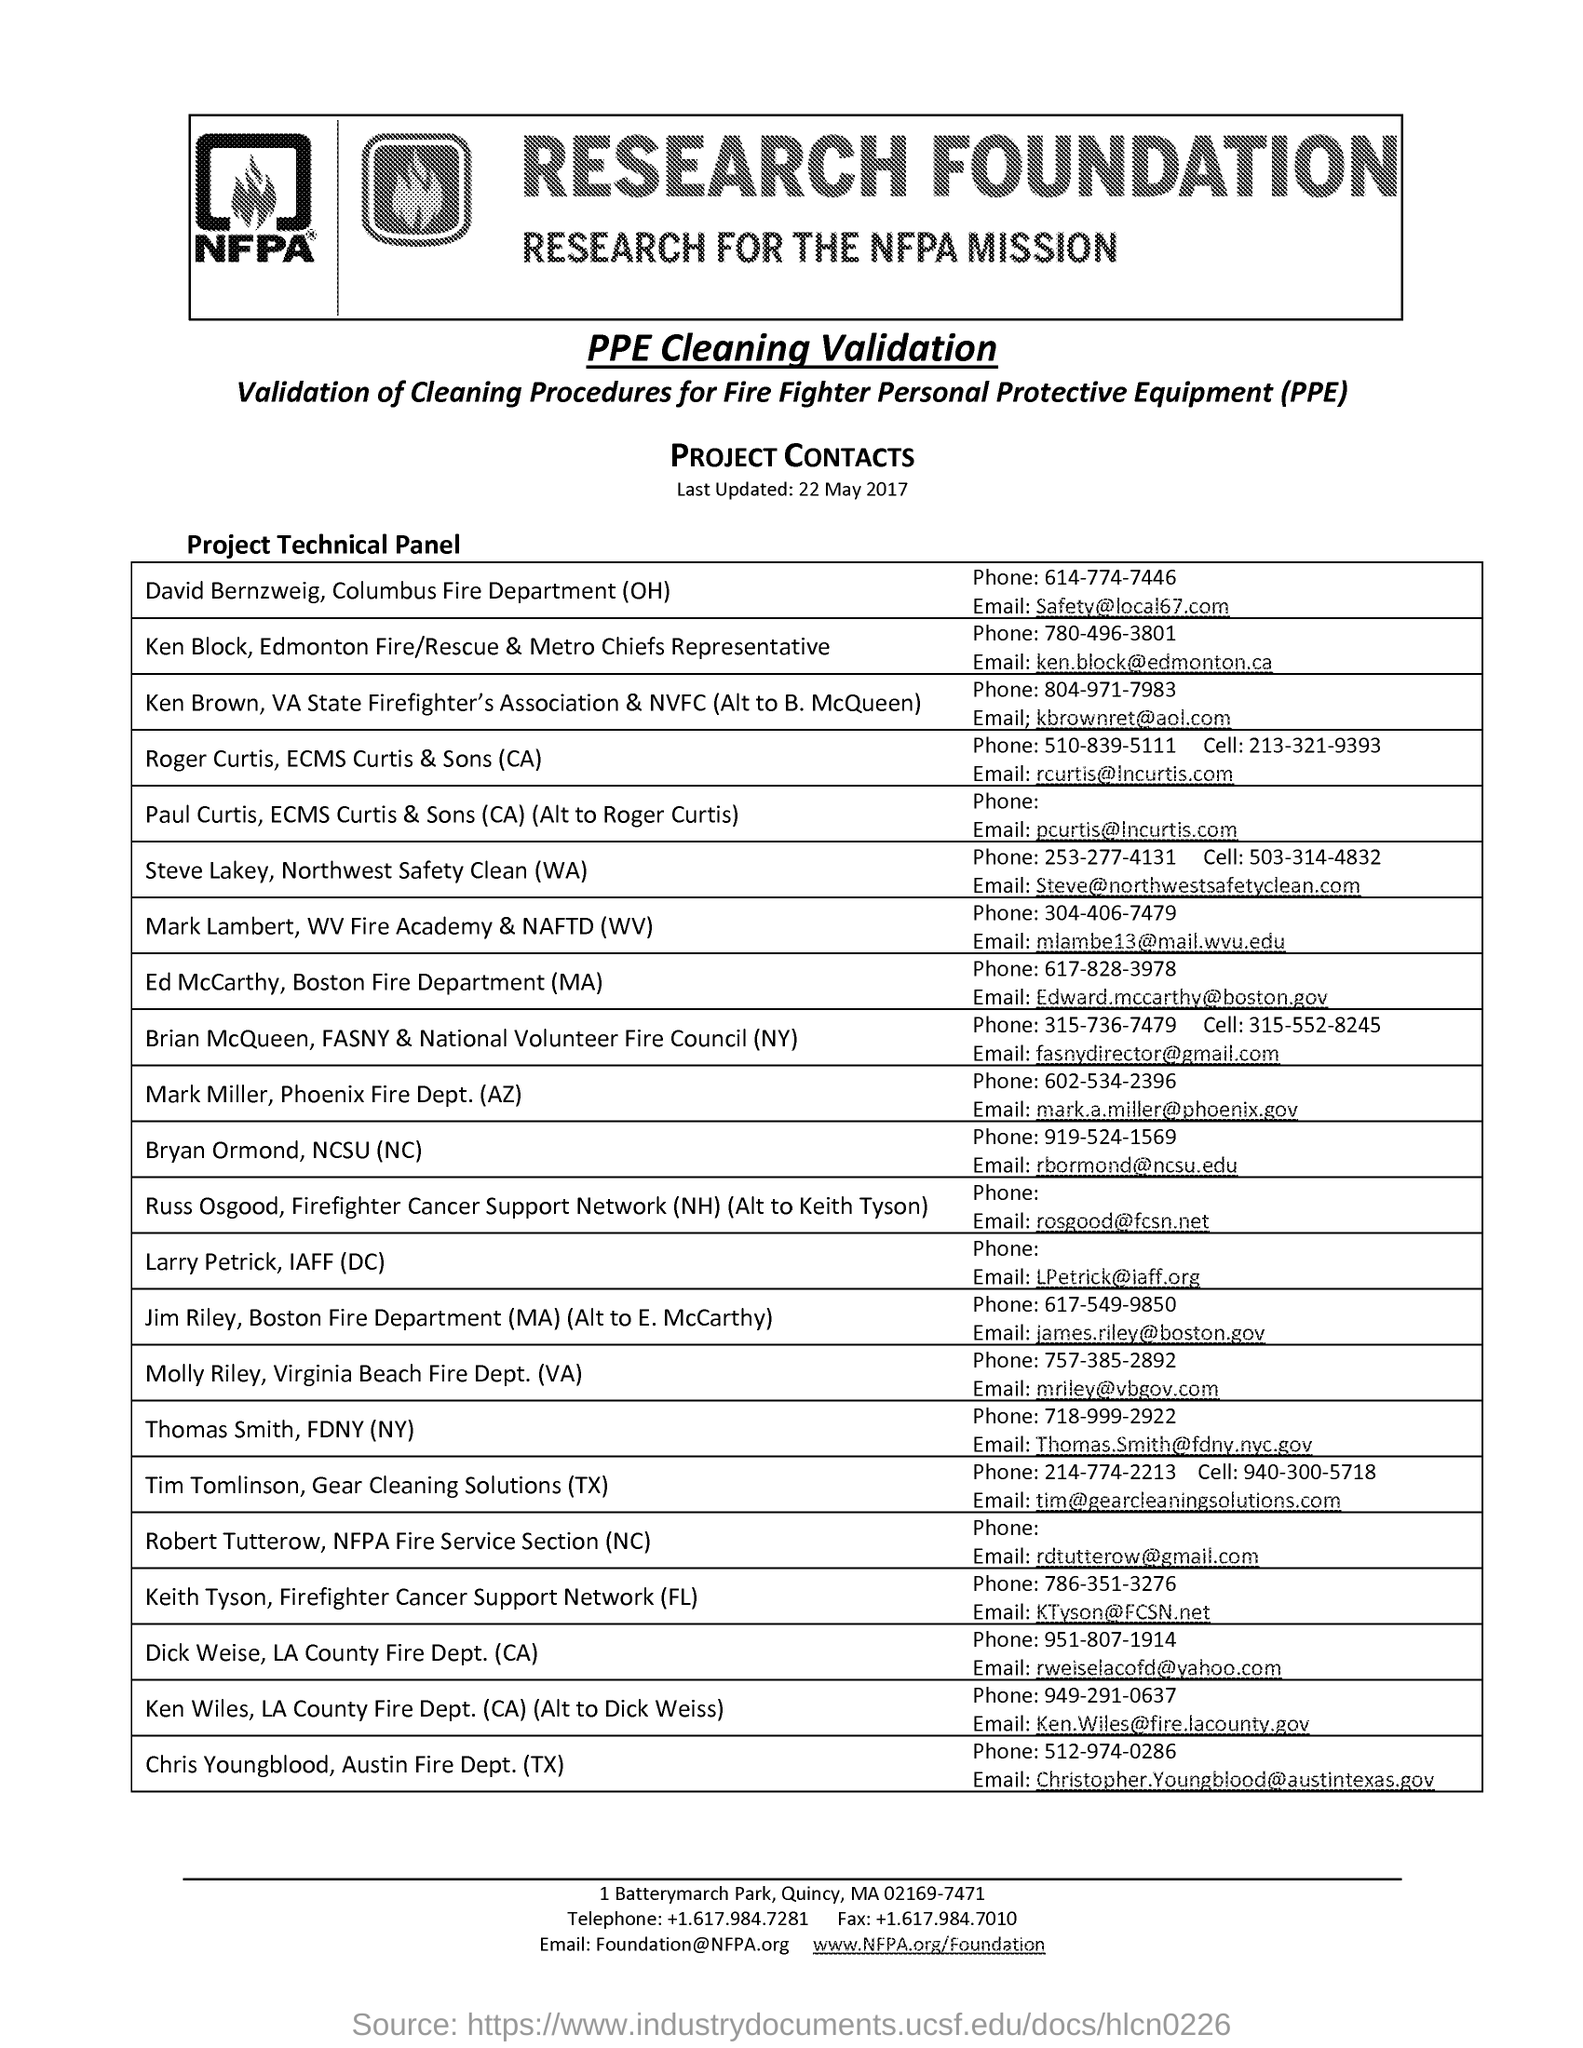Indicate a few pertinent items in this graphic. The subtitle for the Research Foundation is "Research for the NFPA Mission. Personal protective equipment, commonly abbreviated as PPE, is a category of safety gear used to protect individuals from injury or illness while performing their duties. The phone number for David Bernzweig under the list of "project technical panel" is 614-774-7446. Bryan Ormand's email address under the "Project Technical Panel" list is [rbormond@ncsu.edu](mailto:rbormond@ncsu.edu). 